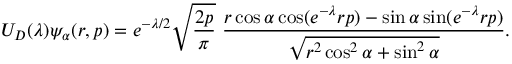<formula> <loc_0><loc_0><loc_500><loc_500>U _ { D } ( \lambda ) \psi _ { \alpha } ( r , p ) = e ^ { - \lambda / 2 } \sqrt { \frac { 2 p } { \pi } } \ \frac { r \cos \alpha \cos ( e ^ { - \lambda } r p ) - \sin \alpha \sin ( e ^ { - \lambda } r p ) } { \sqrt { r ^ { 2 } \cos ^ { 2 } \alpha + \sin ^ { 2 } \alpha } } .</formula> 